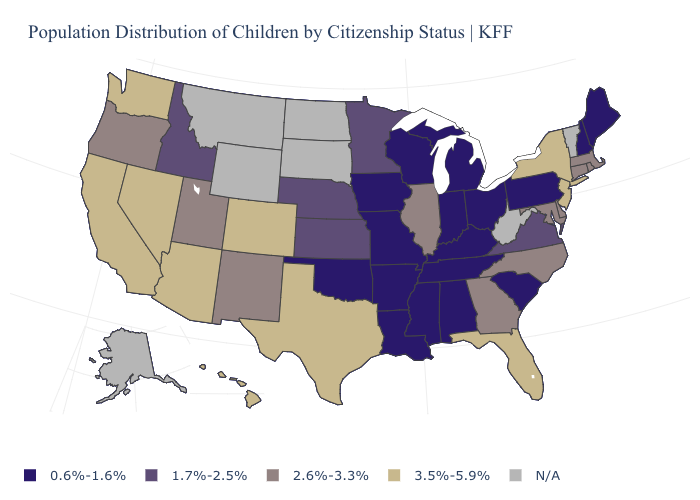What is the value of Virginia?
Keep it brief. 1.7%-2.5%. Name the states that have a value in the range 1.7%-2.5%?
Answer briefly. Idaho, Kansas, Minnesota, Nebraska, Virginia. What is the value of North Carolina?
Give a very brief answer. 2.6%-3.3%. Is the legend a continuous bar?
Be succinct. No. What is the value of Hawaii?
Concise answer only. 3.5%-5.9%. What is the lowest value in the USA?
Give a very brief answer. 0.6%-1.6%. What is the value of Nevada?
Be succinct. 3.5%-5.9%. Name the states that have a value in the range 2.6%-3.3%?
Concise answer only. Connecticut, Delaware, Georgia, Illinois, Maryland, Massachusetts, New Mexico, North Carolina, Oregon, Rhode Island, Utah. Name the states that have a value in the range 2.6%-3.3%?
Answer briefly. Connecticut, Delaware, Georgia, Illinois, Maryland, Massachusetts, New Mexico, North Carolina, Oregon, Rhode Island, Utah. Name the states that have a value in the range 0.6%-1.6%?
Keep it brief. Alabama, Arkansas, Indiana, Iowa, Kentucky, Louisiana, Maine, Michigan, Mississippi, Missouri, New Hampshire, Ohio, Oklahoma, Pennsylvania, South Carolina, Tennessee, Wisconsin. Among the states that border Washington , does Idaho have the lowest value?
Keep it brief. Yes. What is the value of Wisconsin?
Keep it brief. 0.6%-1.6%. 